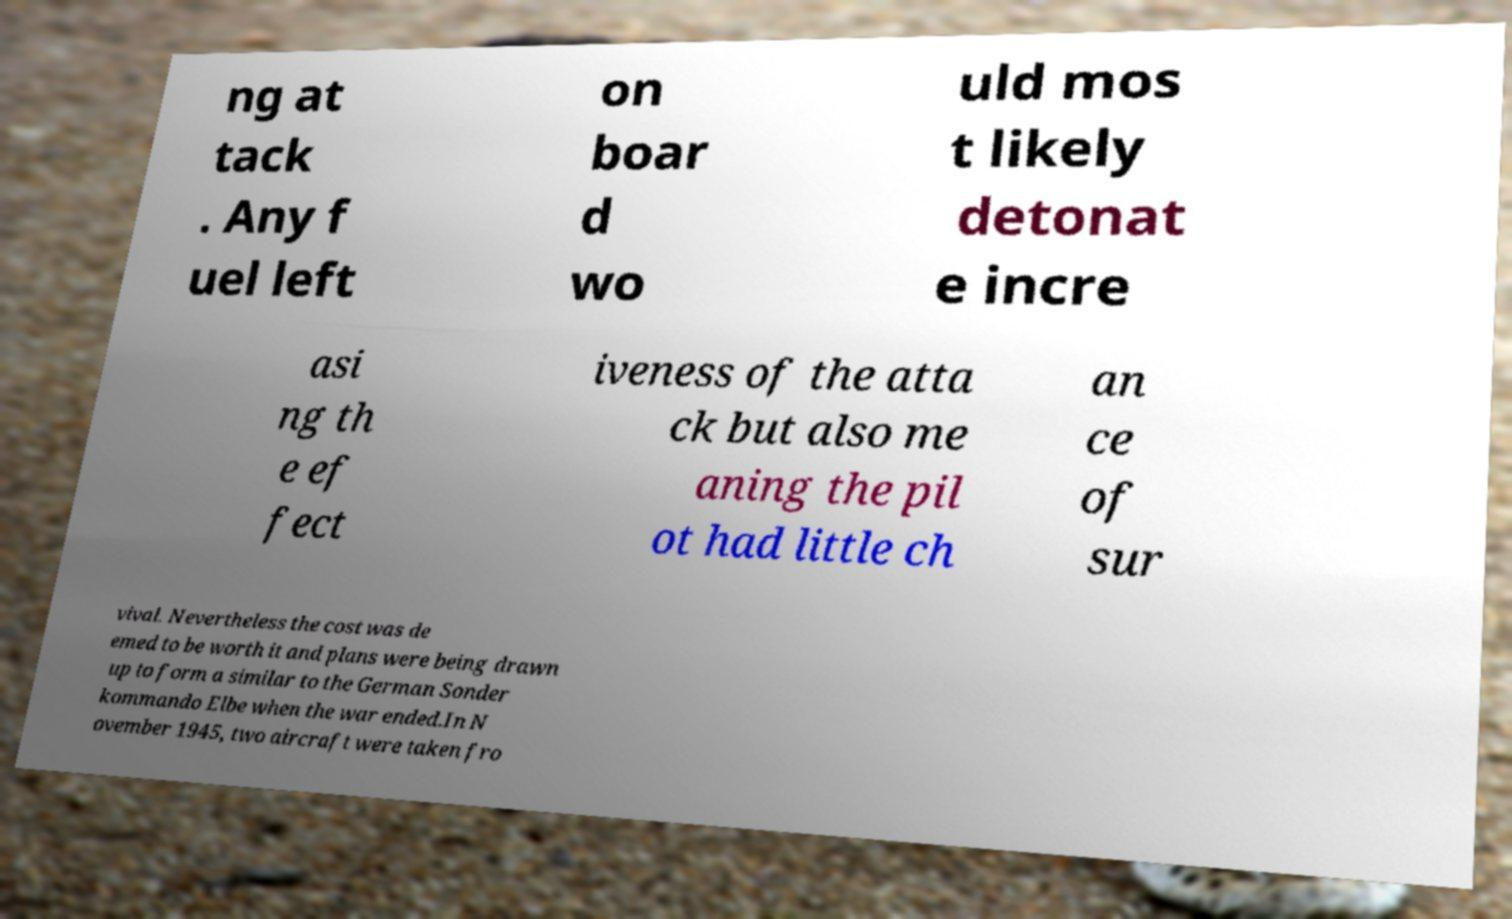Can you accurately transcribe the text from the provided image for me? ng at tack . Any f uel left on boar d wo uld mos t likely detonat e incre asi ng th e ef fect iveness of the atta ck but also me aning the pil ot had little ch an ce of sur vival. Nevertheless the cost was de emed to be worth it and plans were being drawn up to form a similar to the German Sonder kommando Elbe when the war ended.In N ovember 1945, two aircraft were taken fro 